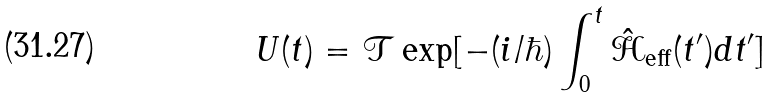Convert formula to latex. <formula><loc_0><loc_0><loc_500><loc_500>U ( t ) = \mathcal { T } \exp [ - ( i / \hbar { ) } \int ^ { t } _ { 0 } \hat { \mathcal { H } } _ { \text {eff} } ( t ^ { \prime } ) d t ^ { \prime } ]</formula> 